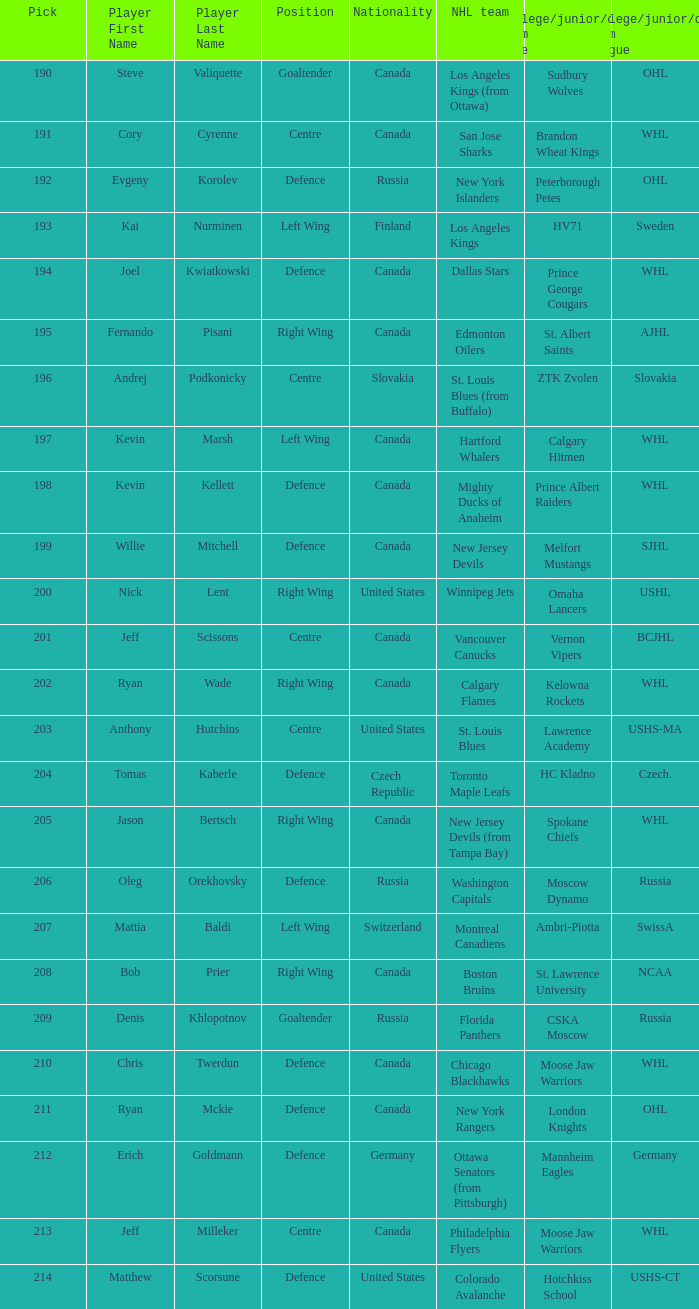Name the pick for matthew scorsune 214.0. 